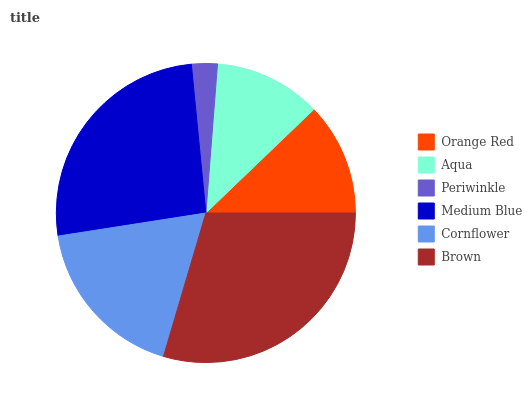Is Periwinkle the minimum?
Answer yes or no. Yes. Is Brown the maximum?
Answer yes or no. Yes. Is Aqua the minimum?
Answer yes or no. No. Is Aqua the maximum?
Answer yes or no. No. Is Orange Red greater than Aqua?
Answer yes or no. Yes. Is Aqua less than Orange Red?
Answer yes or no. Yes. Is Aqua greater than Orange Red?
Answer yes or no. No. Is Orange Red less than Aqua?
Answer yes or no. No. Is Cornflower the high median?
Answer yes or no. Yes. Is Orange Red the low median?
Answer yes or no. Yes. Is Orange Red the high median?
Answer yes or no. No. Is Brown the low median?
Answer yes or no. No. 